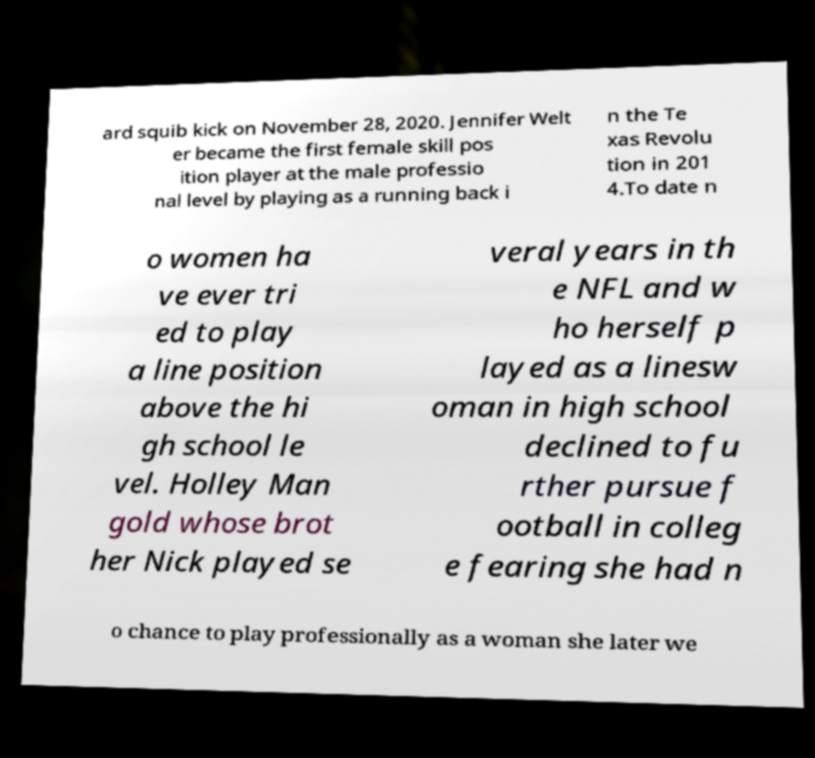Can you read and provide the text displayed in the image?This photo seems to have some interesting text. Can you extract and type it out for me? ard squib kick on November 28, 2020. Jennifer Welt er became the first female skill pos ition player at the male professio nal level by playing as a running back i n the Te xas Revolu tion in 201 4.To date n o women ha ve ever tri ed to play a line position above the hi gh school le vel. Holley Man gold whose brot her Nick played se veral years in th e NFL and w ho herself p layed as a linesw oman in high school declined to fu rther pursue f ootball in colleg e fearing she had n o chance to play professionally as a woman she later we 